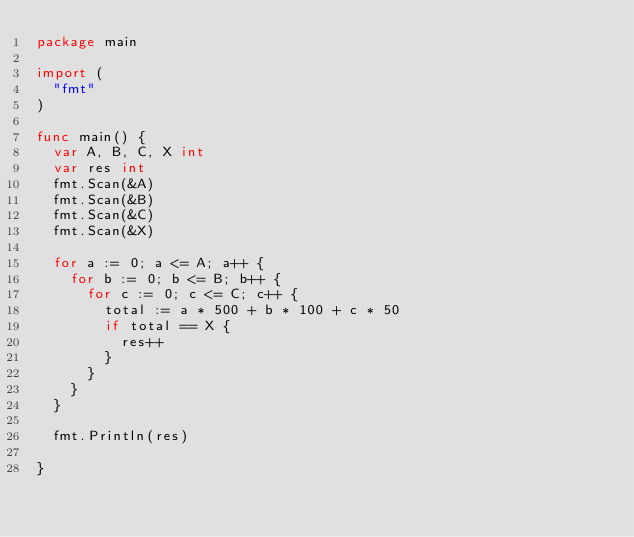Convert code to text. <code><loc_0><loc_0><loc_500><loc_500><_Go_>package main

import (
	"fmt"
)

func main() {
	var A, B, C, X int
	var res int
	fmt.Scan(&A)
	fmt.Scan(&B)
	fmt.Scan(&C)
	fmt.Scan(&X)

	for a := 0; a <= A; a++ {
		for b := 0; b <= B; b++ {
			for c := 0; c <= C; c++ {
				total := a * 500 + b * 100 + c * 50
				if total == X {
					res++
				}
			}
		}
	}

	fmt.Println(res)
	
}</code> 